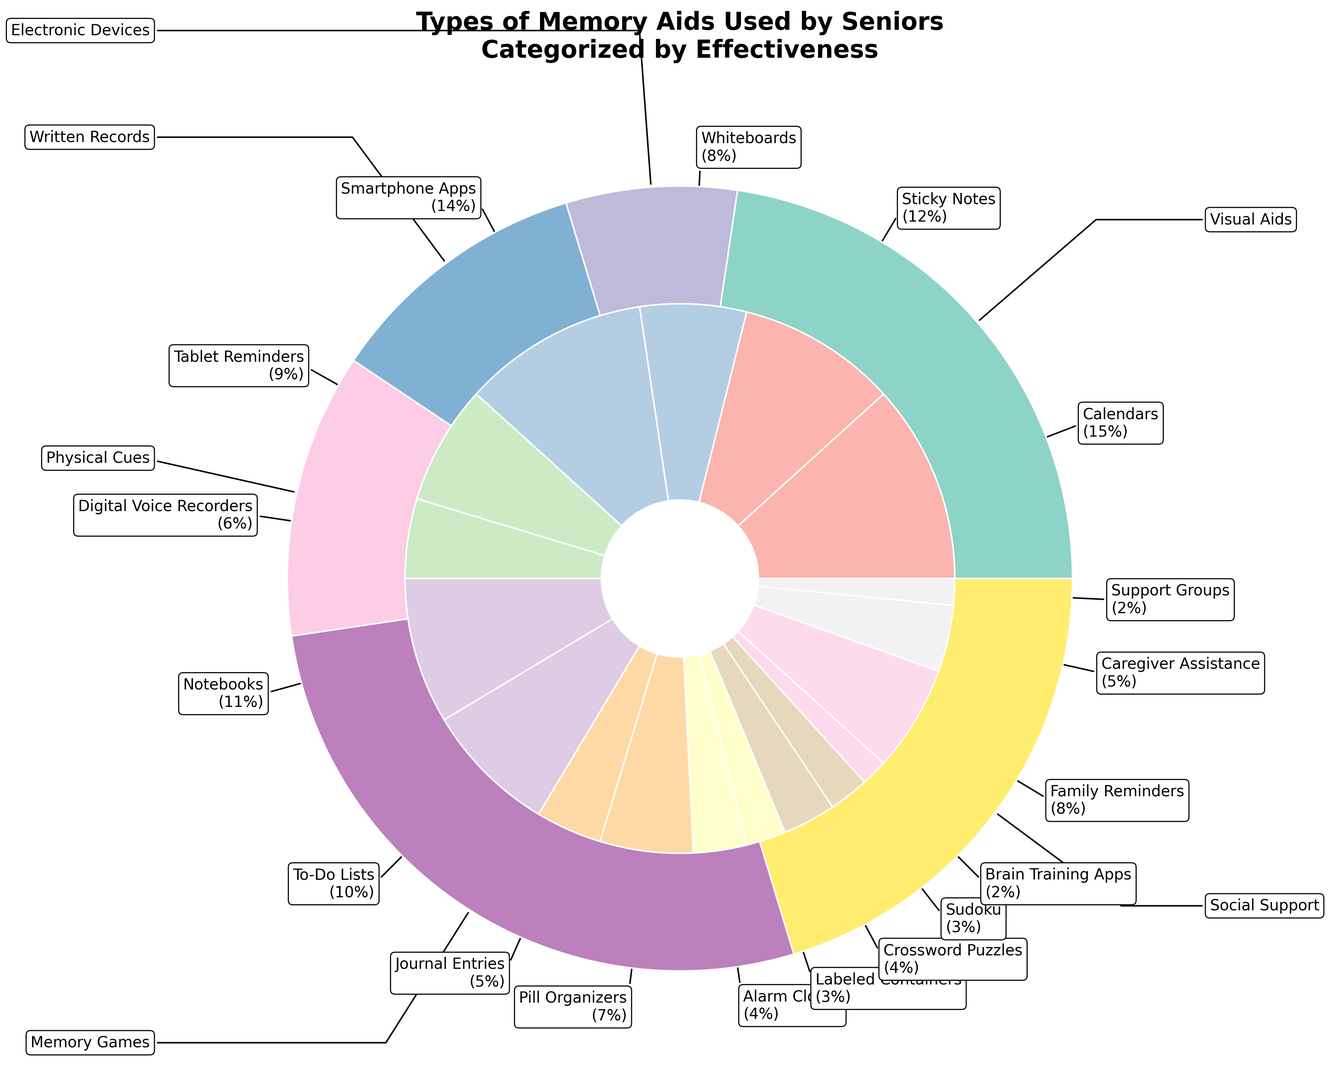what percentage of seniors use visual aids like calendars and sticky notes combined? Add the percentages for Calendars and Sticky Notes: 15% (Calendars) + 12% (Sticky Notes) = 27%
Answer: 27% which subcategory has the highest percentage within the electronic devices category? Among Smartphone Apps (14%), Tablet Reminders (9%), and Digital Voice Recorders (6%), Smartphone Apps have the highest percentage.
Answer: Smartphone Apps how does the percentage of seniors using notebooks compare to those using smartphone apps? Compare the percentages for Notebooks (11%) and Smartphone Apps (14%). Notebooks have 3% less than Smartphone Apps.
Answer: 3% less what's the combined percentage of seniors using pill organizers, alarm clocks, and labeled containers? Add the percentages for Pill Organizers, Alarm Clocks, and Labeled Containers: 7% + 4% + 3% = 14%
Answer: 14% which memory game has the lowest percentage of use among seniors? Compare the percentages for Crossword Puzzles (4%), Sudoku (3%), and Brain Training Apps (2%). Brain Training Apps have the lowest usage.
Answer: Brain Training Apps how does caregiver assistance compare to digital voice recorders in terms of percentage? Compare the percentages: Caregiver Assistance (5%) and Digital Voice Recorders (6%). Caregiver Assistance is 1% less than Digital Voice Recorders.
Answer: 1% less what percentage of seniors use some form of written records like notebooks, to-do lists, or journal entries? Add the percentages for Notebooks, To-Do Lists, and Journal Entries: 11% + 10% + 5% = 26%
Answer: 26% 